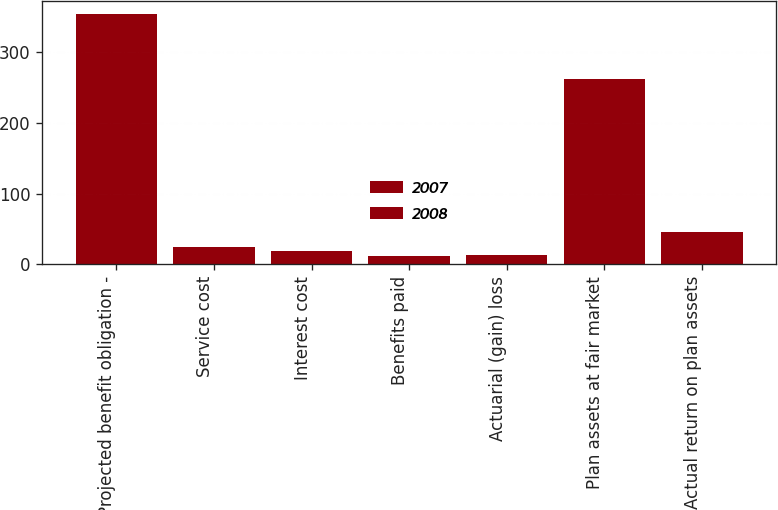Convert chart. <chart><loc_0><loc_0><loc_500><loc_500><stacked_bar_chart><ecel><fcel>Projected benefit obligation -<fcel>Service cost<fcel>Interest cost<fcel>Benefits paid<fcel>Actuarial (gain) loss<fcel>Plan assets at fair market<fcel>Actual return on plan assets<nl><fcel>2007<fcel>188.4<fcel>11.7<fcel>9.7<fcel>9.7<fcel>11.8<fcel>147.2<fcel>39.3<nl><fcel>2008<fcel>166<fcel>13<fcel>8.8<fcel>2.8<fcel>1.9<fcel>115.3<fcel>6.7<nl></chart> 